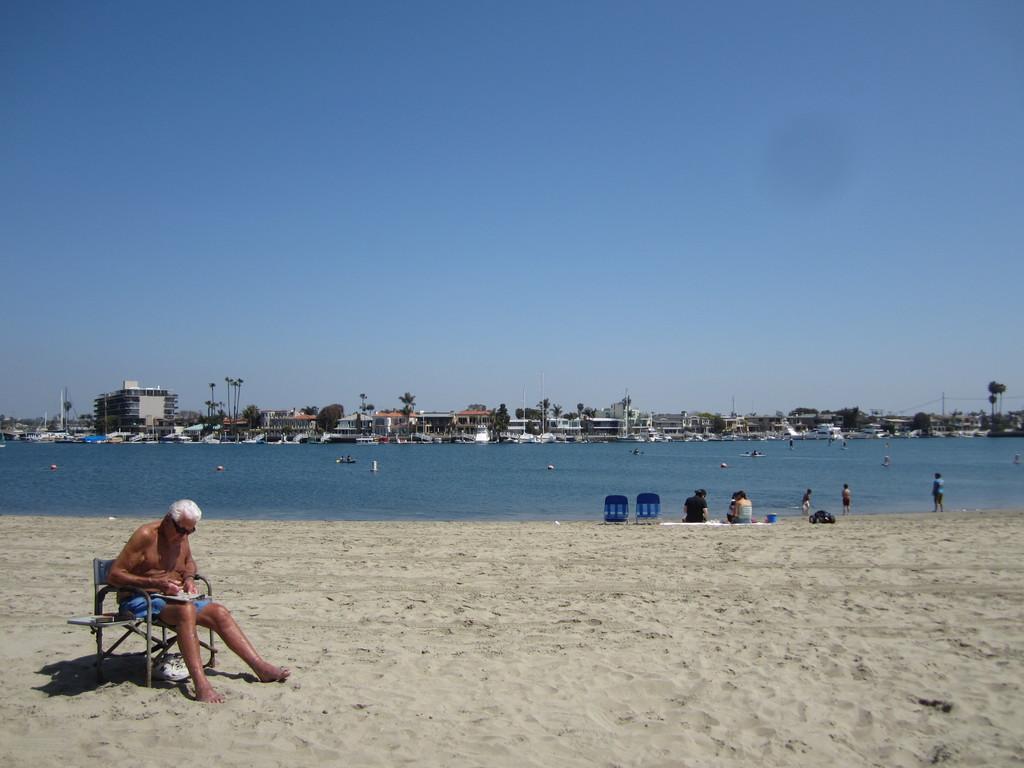In one or two sentences, can you explain what this image depicts? In this image we can see a person wearing goggles. And he is holding something and sitting on a chair. On the ground there is sand. In the background we can see people. Also there is water. And there are buildings and trees. And there is sky. 